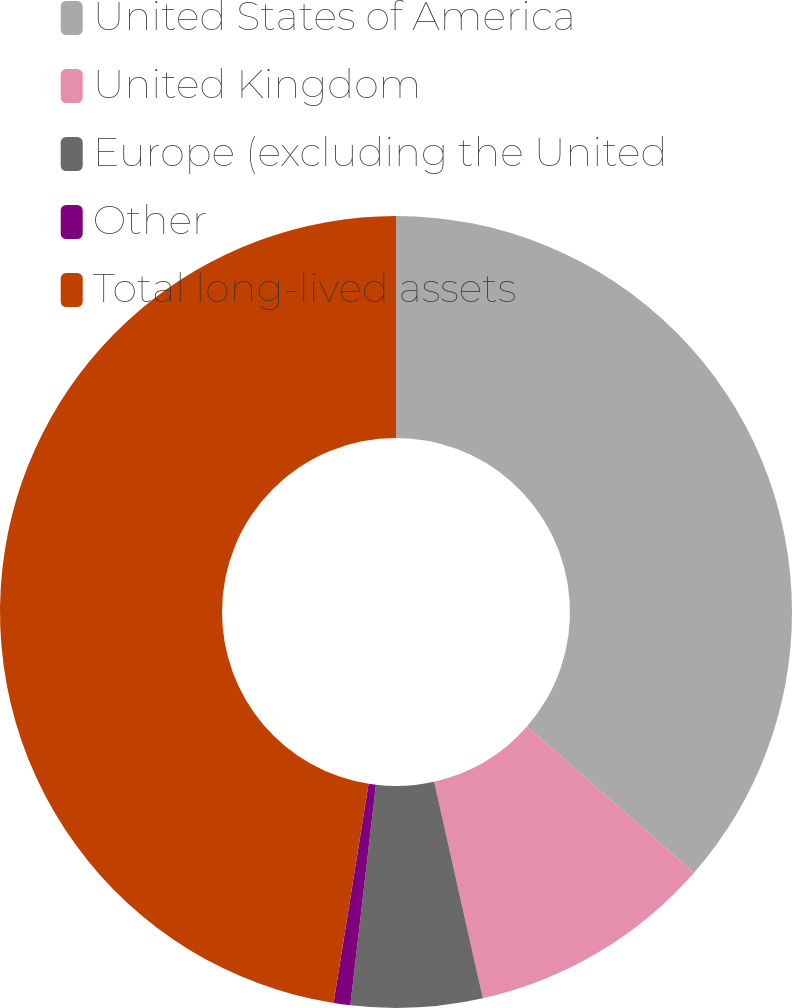Convert chart. <chart><loc_0><loc_0><loc_500><loc_500><pie_chart><fcel>United States of America<fcel>United Kingdom<fcel>Europe (excluding the United<fcel>Other<fcel>Total long-lived assets<nl><fcel>36.44%<fcel>10.04%<fcel>5.36%<fcel>0.68%<fcel>47.48%<nl></chart> 